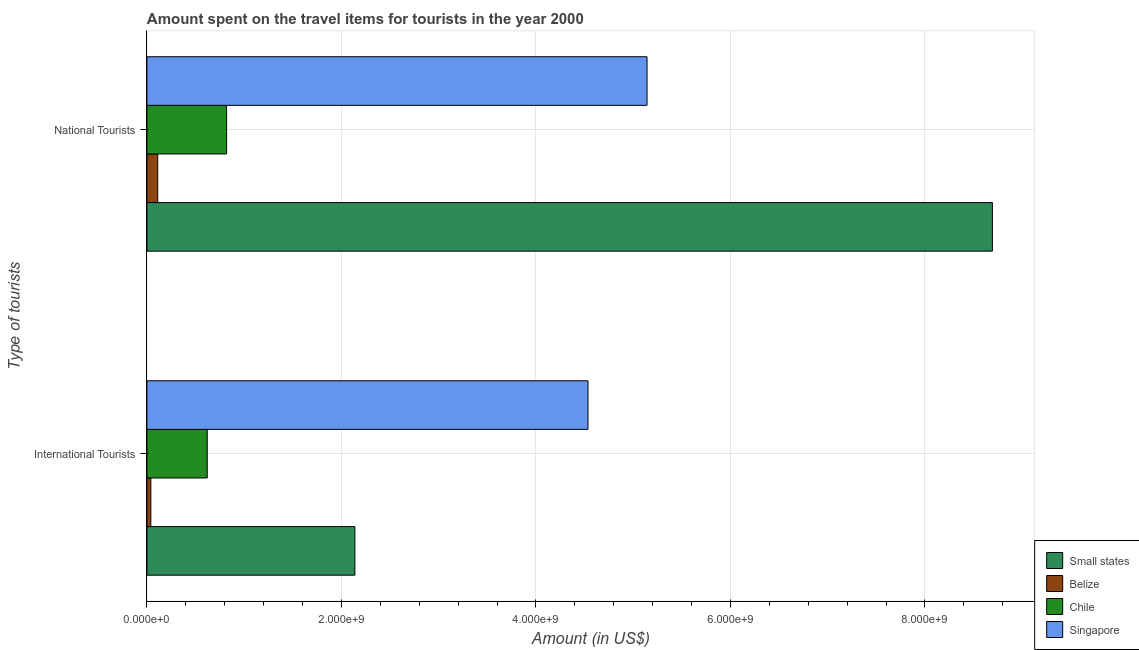How many different coloured bars are there?
Provide a short and direct response. 4. How many groups of bars are there?
Offer a terse response. 2. What is the label of the 1st group of bars from the top?
Provide a succinct answer. National Tourists. What is the amount spent on travel items of international tourists in Small states?
Provide a succinct answer. 2.14e+09. Across all countries, what is the maximum amount spent on travel items of national tourists?
Make the answer very short. 8.69e+09. Across all countries, what is the minimum amount spent on travel items of international tourists?
Provide a short and direct response. 4.00e+07. In which country was the amount spent on travel items of international tourists maximum?
Ensure brevity in your answer.  Singapore. In which country was the amount spent on travel items of national tourists minimum?
Your answer should be very brief. Belize. What is the total amount spent on travel items of national tourists in the graph?
Ensure brevity in your answer.  1.48e+1. What is the difference between the amount spent on travel items of international tourists in Chile and that in Belize?
Offer a very short reply. 5.80e+08. What is the difference between the amount spent on travel items of international tourists in Small states and the amount spent on travel items of national tourists in Belize?
Your answer should be very brief. 2.03e+09. What is the average amount spent on travel items of international tourists per country?
Ensure brevity in your answer.  1.83e+09. What is the difference between the amount spent on travel items of international tourists and amount spent on travel items of national tourists in Belize?
Give a very brief answer. -7.10e+07. In how many countries, is the amount spent on travel items of national tourists greater than 3200000000 US$?
Provide a short and direct response. 2. What is the ratio of the amount spent on travel items of national tourists in Singapore to that in Chile?
Your response must be concise. 6.28. What does the 1st bar from the top in National Tourists represents?
Offer a very short reply. Singapore. What does the 4th bar from the bottom in International Tourists represents?
Make the answer very short. Singapore. Are all the bars in the graph horizontal?
Provide a short and direct response. Yes. How many countries are there in the graph?
Your answer should be compact. 4. What is the difference between two consecutive major ticks on the X-axis?
Your answer should be compact. 2.00e+09. Are the values on the major ticks of X-axis written in scientific E-notation?
Offer a terse response. Yes. Where does the legend appear in the graph?
Provide a short and direct response. Bottom right. How many legend labels are there?
Offer a terse response. 4. How are the legend labels stacked?
Provide a succinct answer. Vertical. What is the title of the graph?
Give a very brief answer. Amount spent on the travel items for tourists in the year 2000. What is the label or title of the X-axis?
Provide a succinct answer. Amount (in US$). What is the label or title of the Y-axis?
Offer a very short reply. Type of tourists. What is the Amount (in US$) in Small states in International Tourists?
Provide a succinct answer. 2.14e+09. What is the Amount (in US$) of Belize in International Tourists?
Your response must be concise. 4.00e+07. What is the Amount (in US$) in Chile in International Tourists?
Offer a terse response. 6.20e+08. What is the Amount (in US$) in Singapore in International Tourists?
Your answer should be very brief. 4.54e+09. What is the Amount (in US$) in Small states in National Tourists?
Offer a terse response. 8.69e+09. What is the Amount (in US$) of Belize in National Tourists?
Make the answer very short. 1.11e+08. What is the Amount (in US$) of Chile in National Tourists?
Ensure brevity in your answer.  8.19e+08. What is the Amount (in US$) in Singapore in National Tourists?
Ensure brevity in your answer.  5.14e+09. Across all Type of tourists, what is the maximum Amount (in US$) in Small states?
Offer a very short reply. 8.69e+09. Across all Type of tourists, what is the maximum Amount (in US$) in Belize?
Provide a short and direct response. 1.11e+08. Across all Type of tourists, what is the maximum Amount (in US$) in Chile?
Give a very brief answer. 8.19e+08. Across all Type of tourists, what is the maximum Amount (in US$) of Singapore?
Give a very brief answer. 5.14e+09. Across all Type of tourists, what is the minimum Amount (in US$) in Small states?
Ensure brevity in your answer.  2.14e+09. Across all Type of tourists, what is the minimum Amount (in US$) in Belize?
Your answer should be compact. 4.00e+07. Across all Type of tourists, what is the minimum Amount (in US$) of Chile?
Your response must be concise. 6.20e+08. Across all Type of tourists, what is the minimum Amount (in US$) of Singapore?
Make the answer very short. 4.54e+09. What is the total Amount (in US$) in Small states in the graph?
Your answer should be very brief. 1.08e+1. What is the total Amount (in US$) in Belize in the graph?
Offer a very short reply. 1.51e+08. What is the total Amount (in US$) in Chile in the graph?
Your answer should be compact. 1.44e+09. What is the total Amount (in US$) of Singapore in the graph?
Provide a short and direct response. 9.68e+09. What is the difference between the Amount (in US$) of Small states in International Tourists and that in National Tourists?
Offer a very short reply. -6.55e+09. What is the difference between the Amount (in US$) of Belize in International Tourists and that in National Tourists?
Keep it short and to the point. -7.10e+07. What is the difference between the Amount (in US$) in Chile in International Tourists and that in National Tourists?
Give a very brief answer. -1.99e+08. What is the difference between the Amount (in US$) of Singapore in International Tourists and that in National Tourists?
Your answer should be very brief. -6.07e+08. What is the difference between the Amount (in US$) in Small states in International Tourists and the Amount (in US$) in Belize in National Tourists?
Keep it short and to the point. 2.03e+09. What is the difference between the Amount (in US$) of Small states in International Tourists and the Amount (in US$) of Chile in National Tourists?
Make the answer very short. 1.32e+09. What is the difference between the Amount (in US$) in Small states in International Tourists and the Amount (in US$) in Singapore in National Tourists?
Make the answer very short. -3.00e+09. What is the difference between the Amount (in US$) in Belize in International Tourists and the Amount (in US$) in Chile in National Tourists?
Your answer should be very brief. -7.79e+08. What is the difference between the Amount (in US$) in Belize in International Tourists and the Amount (in US$) in Singapore in National Tourists?
Offer a terse response. -5.10e+09. What is the difference between the Amount (in US$) in Chile in International Tourists and the Amount (in US$) in Singapore in National Tourists?
Keep it short and to the point. -4.52e+09. What is the average Amount (in US$) in Small states per Type of tourists?
Offer a terse response. 5.42e+09. What is the average Amount (in US$) of Belize per Type of tourists?
Offer a terse response. 7.55e+07. What is the average Amount (in US$) of Chile per Type of tourists?
Provide a short and direct response. 7.20e+08. What is the average Amount (in US$) of Singapore per Type of tourists?
Your response must be concise. 4.84e+09. What is the difference between the Amount (in US$) in Small states and Amount (in US$) in Belize in International Tourists?
Provide a short and direct response. 2.10e+09. What is the difference between the Amount (in US$) in Small states and Amount (in US$) in Chile in International Tourists?
Ensure brevity in your answer.  1.52e+09. What is the difference between the Amount (in US$) in Small states and Amount (in US$) in Singapore in International Tourists?
Provide a short and direct response. -2.40e+09. What is the difference between the Amount (in US$) in Belize and Amount (in US$) in Chile in International Tourists?
Give a very brief answer. -5.80e+08. What is the difference between the Amount (in US$) in Belize and Amount (in US$) in Singapore in International Tourists?
Give a very brief answer. -4.50e+09. What is the difference between the Amount (in US$) in Chile and Amount (in US$) in Singapore in International Tourists?
Offer a very short reply. -3.92e+09. What is the difference between the Amount (in US$) in Small states and Amount (in US$) in Belize in National Tourists?
Keep it short and to the point. 8.58e+09. What is the difference between the Amount (in US$) in Small states and Amount (in US$) in Chile in National Tourists?
Provide a succinct answer. 7.87e+09. What is the difference between the Amount (in US$) in Small states and Amount (in US$) in Singapore in National Tourists?
Provide a succinct answer. 3.55e+09. What is the difference between the Amount (in US$) of Belize and Amount (in US$) of Chile in National Tourists?
Your answer should be compact. -7.08e+08. What is the difference between the Amount (in US$) in Belize and Amount (in US$) in Singapore in National Tourists?
Your response must be concise. -5.03e+09. What is the difference between the Amount (in US$) of Chile and Amount (in US$) of Singapore in National Tourists?
Your answer should be compact. -4.32e+09. What is the ratio of the Amount (in US$) in Small states in International Tourists to that in National Tourists?
Your answer should be compact. 0.25. What is the ratio of the Amount (in US$) of Belize in International Tourists to that in National Tourists?
Your answer should be very brief. 0.36. What is the ratio of the Amount (in US$) of Chile in International Tourists to that in National Tourists?
Ensure brevity in your answer.  0.76. What is the ratio of the Amount (in US$) in Singapore in International Tourists to that in National Tourists?
Provide a short and direct response. 0.88. What is the difference between the highest and the second highest Amount (in US$) in Small states?
Your answer should be compact. 6.55e+09. What is the difference between the highest and the second highest Amount (in US$) of Belize?
Your response must be concise. 7.10e+07. What is the difference between the highest and the second highest Amount (in US$) of Chile?
Keep it short and to the point. 1.99e+08. What is the difference between the highest and the second highest Amount (in US$) of Singapore?
Provide a short and direct response. 6.07e+08. What is the difference between the highest and the lowest Amount (in US$) in Small states?
Your response must be concise. 6.55e+09. What is the difference between the highest and the lowest Amount (in US$) in Belize?
Give a very brief answer. 7.10e+07. What is the difference between the highest and the lowest Amount (in US$) in Chile?
Give a very brief answer. 1.99e+08. What is the difference between the highest and the lowest Amount (in US$) of Singapore?
Your response must be concise. 6.07e+08. 